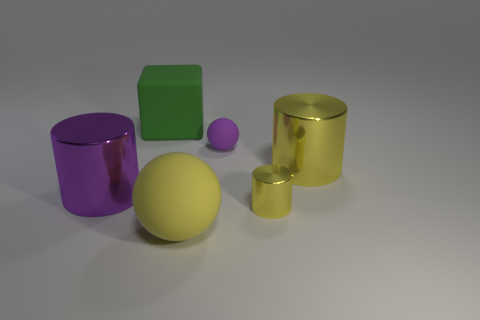Subtract all gray blocks. How many yellow cylinders are left? 2 Add 3 small red metallic cylinders. How many objects exist? 9 Subtract all large cylinders. How many cylinders are left? 1 Subtract all spheres. How many objects are left? 4 Subtract all cyan cylinders. Subtract all red blocks. How many cylinders are left? 3 Add 1 big blocks. How many big blocks are left? 2 Add 1 small green spheres. How many small green spheres exist? 1 Subtract 1 green cubes. How many objects are left? 5 Subtract all metallic spheres. Subtract all big green objects. How many objects are left? 5 